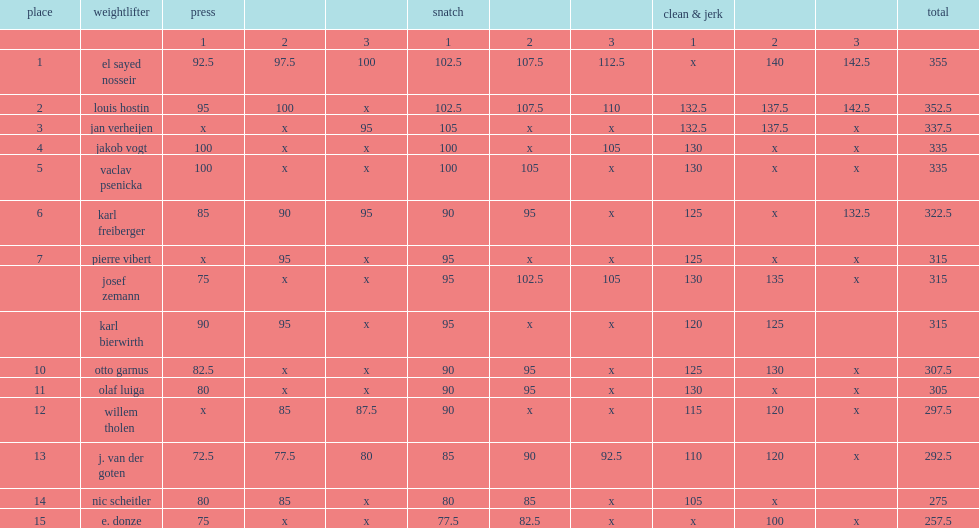How many kilograms did el sayed nosseir lift in snatch? 112.5. How many kilograms did el sayed nosseir lift in total of the three lifts? 355.0. 